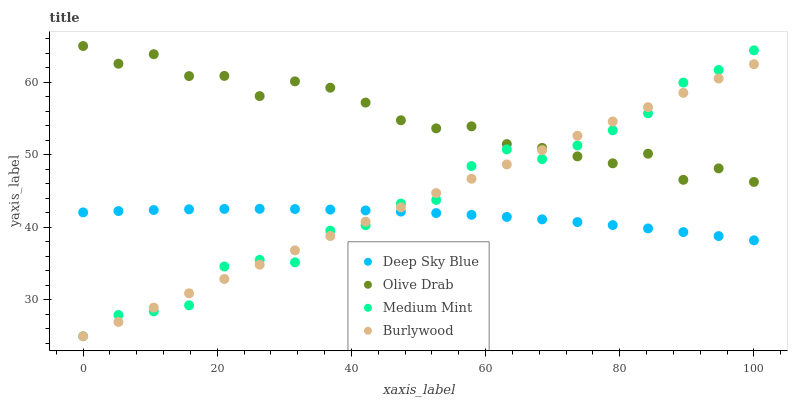Does Deep Sky Blue have the minimum area under the curve?
Answer yes or no. Yes. Does Olive Drab have the maximum area under the curve?
Answer yes or no. Yes. Does Burlywood have the minimum area under the curve?
Answer yes or no. No. Does Burlywood have the maximum area under the curve?
Answer yes or no. No. Is Burlywood the smoothest?
Answer yes or no. Yes. Is Olive Drab the roughest?
Answer yes or no. Yes. Is Olive Drab the smoothest?
Answer yes or no. No. Is Burlywood the roughest?
Answer yes or no. No. Does Medium Mint have the lowest value?
Answer yes or no. Yes. Does Olive Drab have the lowest value?
Answer yes or no. No. Does Olive Drab have the highest value?
Answer yes or no. Yes. Does Burlywood have the highest value?
Answer yes or no. No. Is Deep Sky Blue less than Olive Drab?
Answer yes or no. Yes. Is Olive Drab greater than Deep Sky Blue?
Answer yes or no. Yes. Does Burlywood intersect Deep Sky Blue?
Answer yes or no. Yes. Is Burlywood less than Deep Sky Blue?
Answer yes or no. No. Is Burlywood greater than Deep Sky Blue?
Answer yes or no. No. Does Deep Sky Blue intersect Olive Drab?
Answer yes or no. No. 